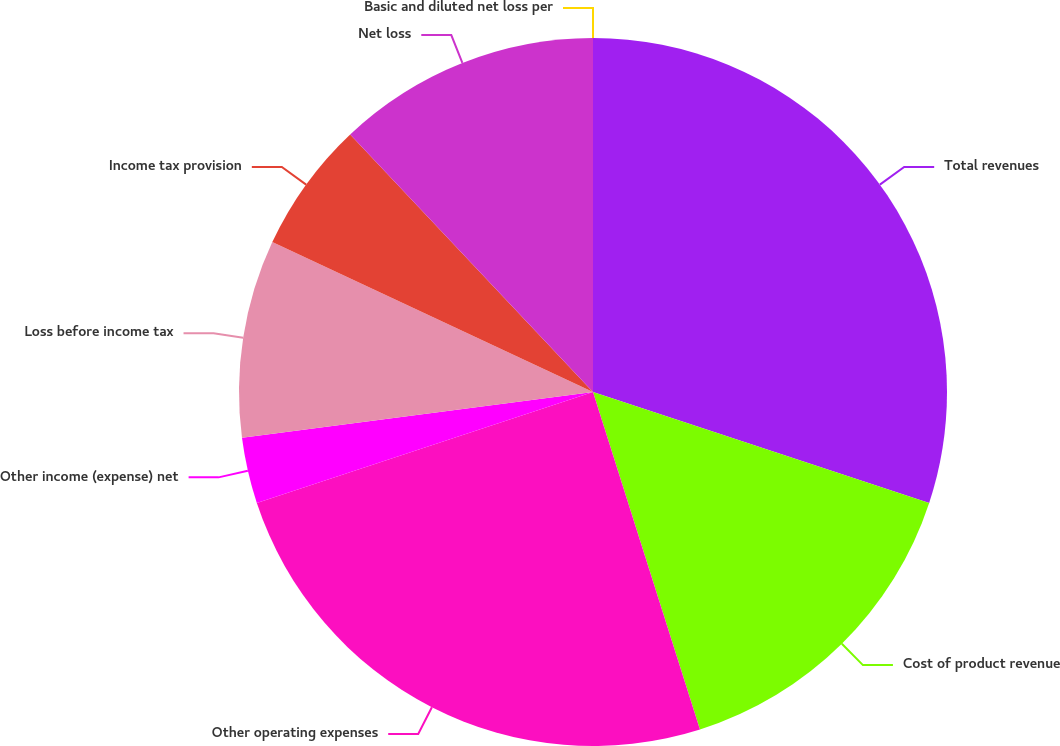<chart> <loc_0><loc_0><loc_500><loc_500><pie_chart><fcel>Total revenues<fcel>Cost of product revenue<fcel>Other operating expenses<fcel>Other income (expense) net<fcel>Loss before income tax<fcel>Income tax provision<fcel>Net loss<fcel>Basic and diluted net loss per<nl><fcel>30.07%<fcel>15.04%<fcel>24.81%<fcel>3.01%<fcel>9.02%<fcel>6.01%<fcel>12.03%<fcel>0.0%<nl></chart> 